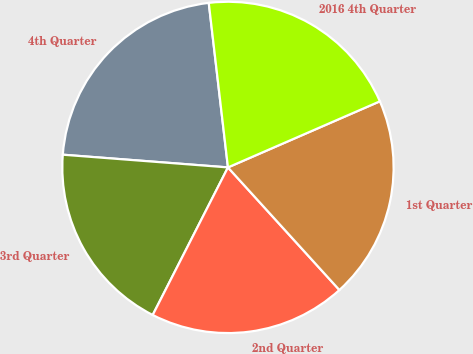Convert chart. <chart><loc_0><loc_0><loc_500><loc_500><pie_chart><fcel>4th Quarter<fcel>3rd Quarter<fcel>2nd Quarter<fcel>1st Quarter<fcel>2016 4th Quarter<nl><fcel>21.93%<fcel>18.72%<fcel>19.25%<fcel>19.79%<fcel>20.32%<nl></chart> 